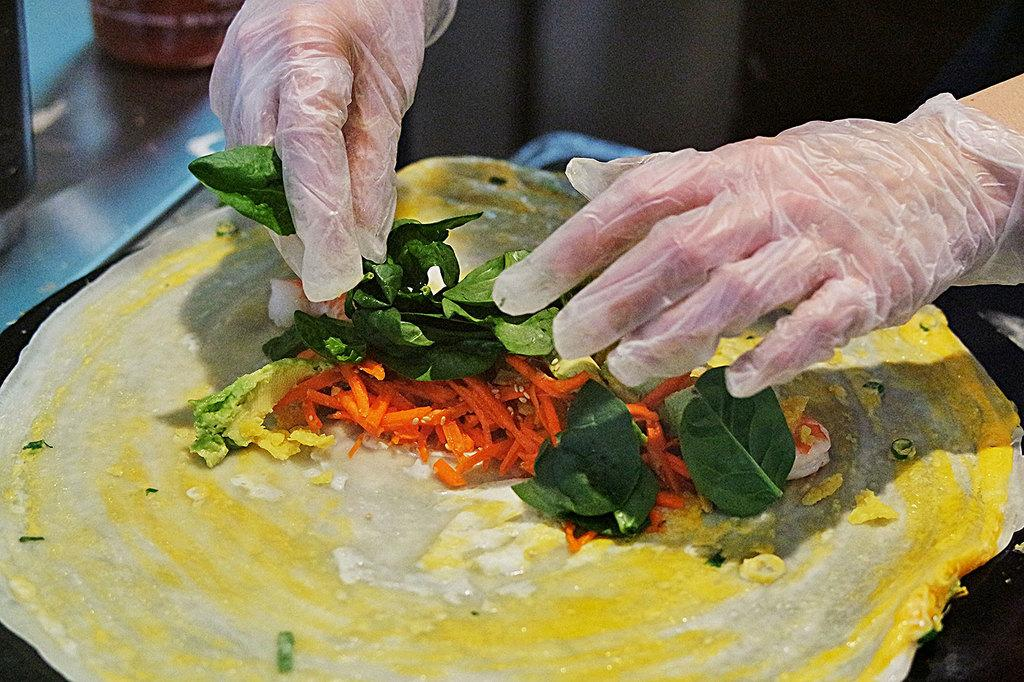What type of food item can be seen in the image? Unfortunately, the specific type of food item cannot be determined from the provided facts. What can be seen in the image besides the food item? A person's hands are visible in the image. How many trains are visible in the image? There are no trains present in the image. What type of seed is being pushed by the person in the image? There is no seed or pushing action depicted in the image. 